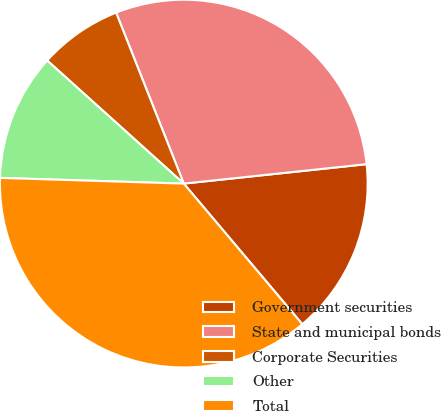Convert chart to OTSL. <chart><loc_0><loc_0><loc_500><loc_500><pie_chart><fcel>Government securities<fcel>State and municipal bonds<fcel>Corporate Securities<fcel>Other<fcel>Total<nl><fcel>15.54%<fcel>29.31%<fcel>7.33%<fcel>11.18%<fcel>36.64%<nl></chart> 